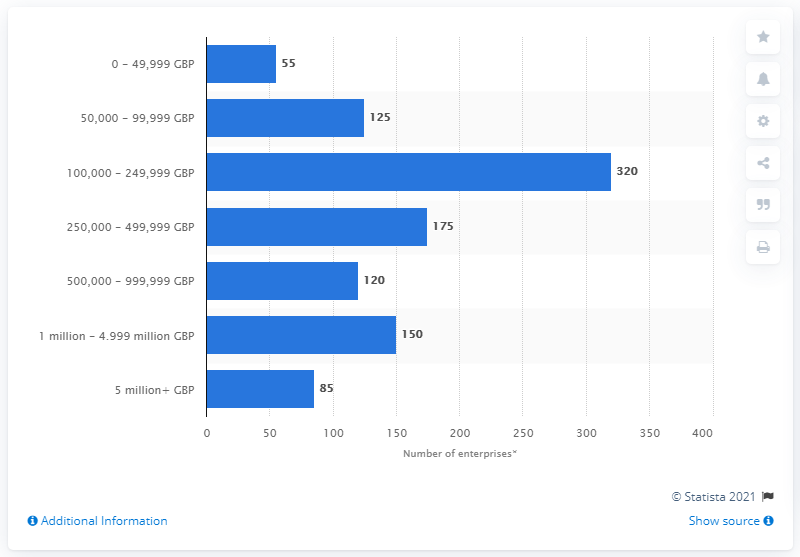List a handful of essential elements in this visual. As of March 2020, it was reported that 85 enterprises in the gambling and betting activities sector had a turnover of more than 5 million GBP. 